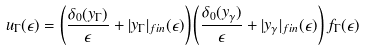<formula> <loc_0><loc_0><loc_500><loc_500>u _ { \Gamma } ( \epsilon ) = \left ( \frac { \delta _ { 0 } ( y _ { \Gamma } ) } { \epsilon } + | y _ { \Gamma } | _ { f i n } ( \epsilon ) \right ) \left ( \frac { \delta _ { 0 } ( y _ { \gamma } ) } { \epsilon } + | y _ { \gamma } | _ { f i n } ( \epsilon ) \right ) f _ { \Gamma } ( \epsilon )</formula> 